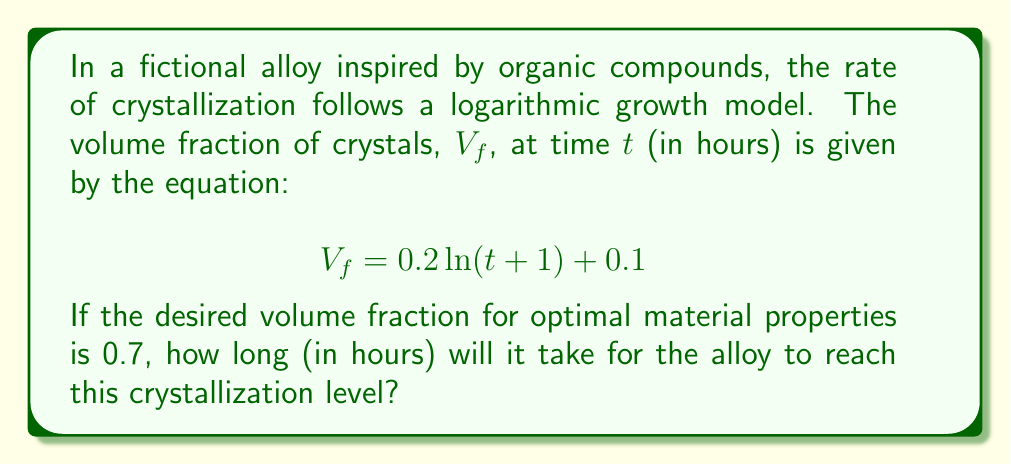Could you help me with this problem? To solve this problem, we need to follow these steps:

1) We start with the given equation:
   $$V_f = 0.2 \ln(t+1) + 0.1$$

2) We want to find $t$ when $V_f = 0.7$. Let's substitute this:
   $$0.7 = 0.2 \ln(t+1) + 0.1$$

3) Subtract 0.1 from both sides:
   $$0.6 = 0.2 \ln(t+1)$$

4) Divide both sides by 0.2:
   $$3 = \ln(t+1)$$

5) To isolate $t$, we need to apply the exponential function (inverse of natural log) to both sides:
   $$e^3 = t+1$$

6) Subtract 1 from both sides:
   $$e^3 - 1 = t$$

7) Calculate the value:
   $$t = e^3 - 1 \approx 19.0855$$

8) Since time must be a whole number of hours in this context, we round up to the nearest hour.
Answer: 20 hours 